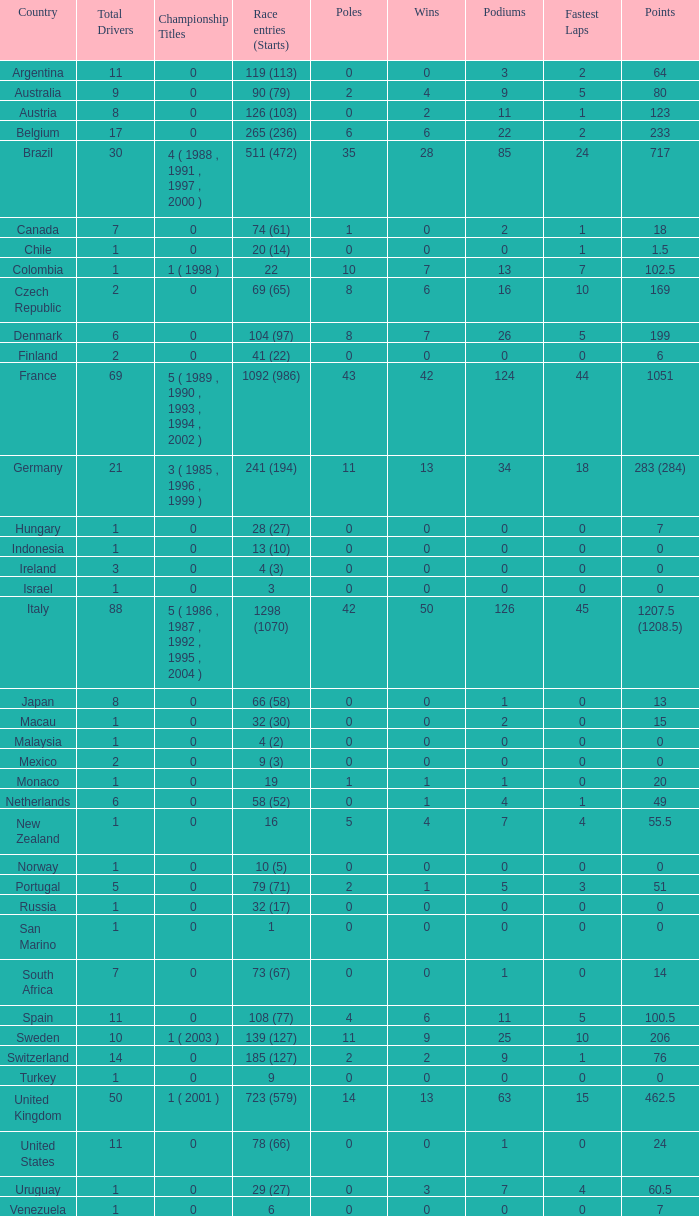How many fastest laps are there for a nation that has 32 (30) entries and starts and fewer than two podiums? None. 